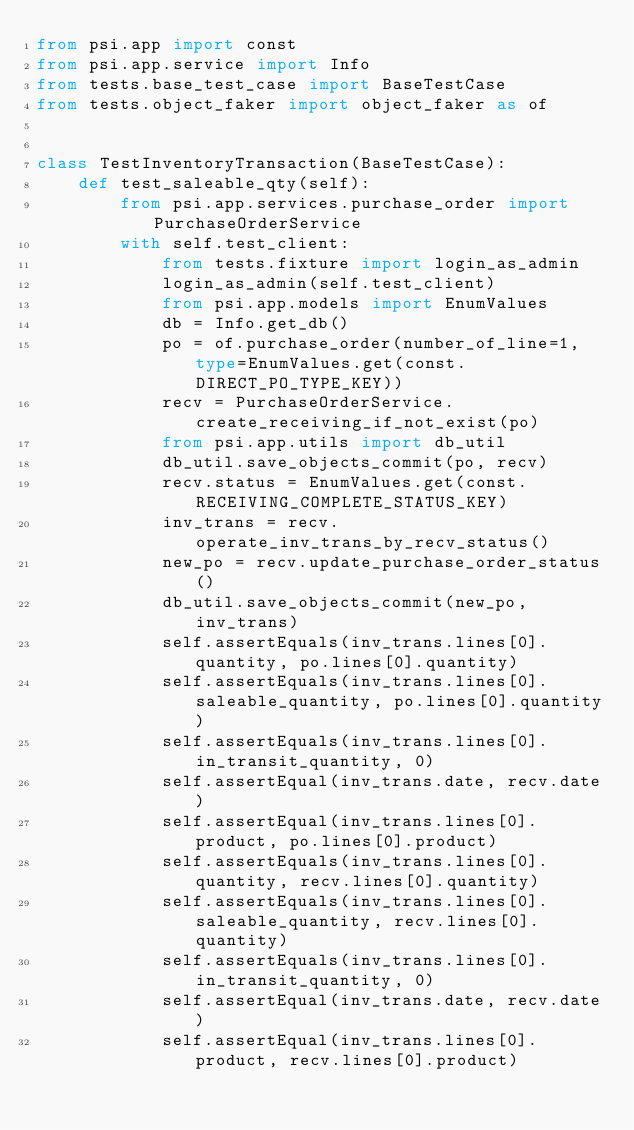Convert code to text. <code><loc_0><loc_0><loc_500><loc_500><_Python_>from psi.app import const
from psi.app.service import Info
from tests.base_test_case import BaseTestCase
from tests.object_faker import object_faker as of


class TestInventoryTransaction(BaseTestCase):
    def test_saleable_qty(self):
        from psi.app.services.purchase_order import PurchaseOrderService
        with self.test_client:
            from tests.fixture import login_as_admin
            login_as_admin(self.test_client)
            from psi.app.models import EnumValues
            db = Info.get_db()
            po = of.purchase_order(number_of_line=1, type=EnumValues.get(const.DIRECT_PO_TYPE_KEY))
            recv = PurchaseOrderService.create_receiving_if_not_exist(po)
            from psi.app.utils import db_util
            db_util.save_objects_commit(po, recv)
            recv.status = EnumValues.get(const.RECEIVING_COMPLETE_STATUS_KEY)
            inv_trans = recv.operate_inv_trans_by_recv_status()
            new_po = recv.update_purchase_order_status()
            db_util.save_objects_commit(new_po, inv_trans)
            self.assertEquals(inv_trans.lines[0].quantity, po.lines[0].quantity)
            self.assertEquals(inv_trans.lines[0].saleable_quantity, po.lines[0].quantity)
            self.assertEquals(inv_trans.lines[0].in_transit_quantity, 0)
            self.assertEqual(inv_trans.date, recv.date)
            self.assertEqual(inv_trans.lines[0].product, po.lines[0].product)
            self.assertEquals(inv_trans.lines[0].quantity, recv.lines[0].quantity)
            self.assertEquals(inv_trans.lines[0].saleable_quantity, recv.lines[0].quantity)
            self.assertEquals(inv_trans.lines[0].in_transit_quantity, 0)
            self.assertEqual(inv_trans.date, recv.date)
            self.assertEqual(inv_trans.lines[0].product, recv.lines[0].product)




</code> 